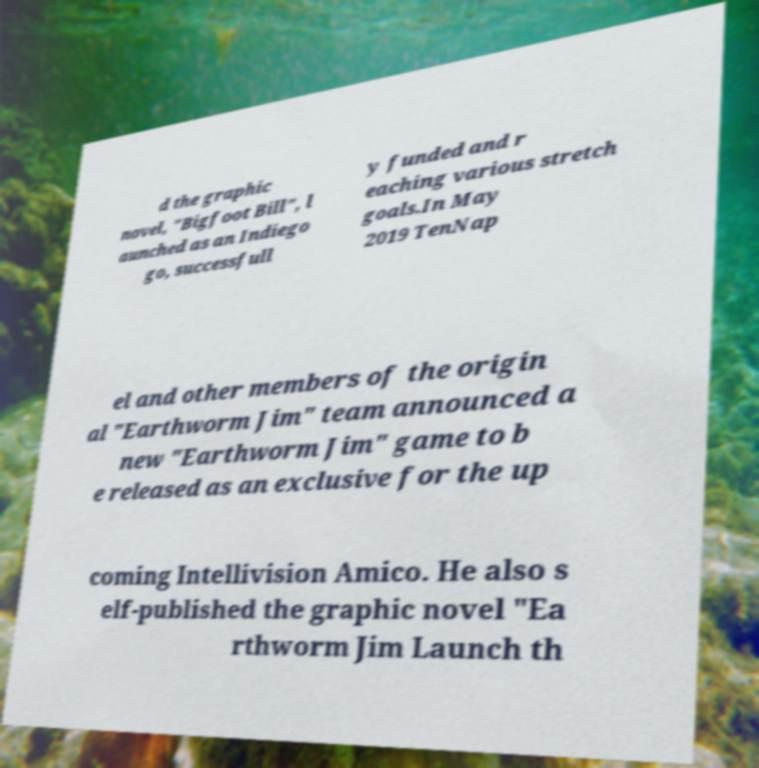There's text embedded in this image that I need extracted. Can you transcribe it verbatim? d the graphic novel, "Bigfoot Bill", l aunched as an Indiego go, successfull y funded and r eaching various stretch goals.In May 2019 TenNap el and other members of the origin al "Earthworm Jim" team announced a new "Earthworm Jim" game to b e released as an exclusive for the up coming Intellivision Amico. He also s elf-published the graphic novel "Ea rthworm Jim Launch th 